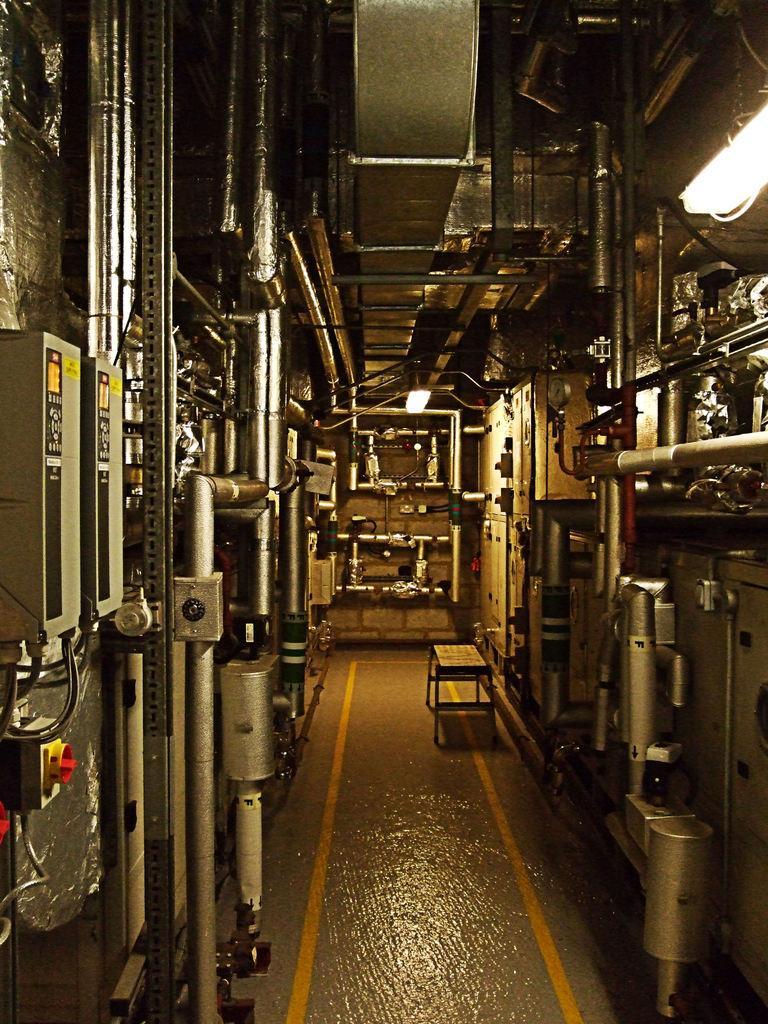Please provide a concise description of this image. This picture looks like few machines and a small table and I can see light. 